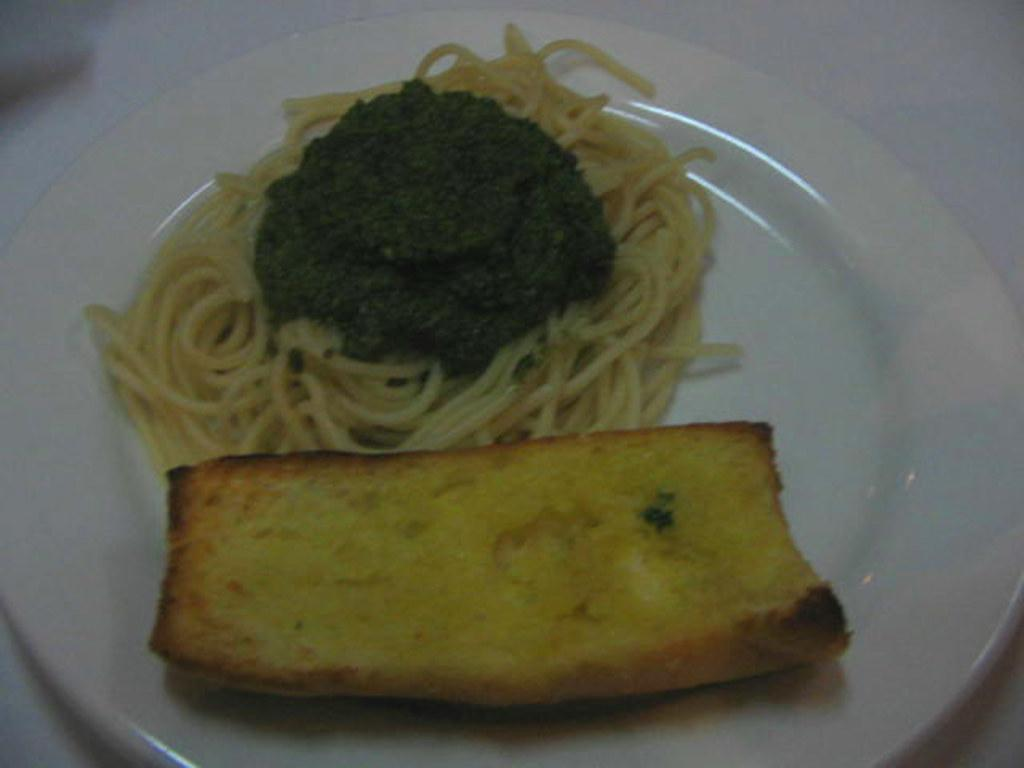What is the main subject of the image? There is a food item in the image. How is the food item presented in the image? The food item is on a plate. Where is the plate with the food item located? The plate is placed on a surface that resembles a table. What type of farm animals can be seen grazing in the image? There are no farm animals present in the image; it features a food item on a plate. What color is the lunchroom in the image? The image does not show a lunchroom; it only shows a food item on a plate placed on a surface that resembles a table. 